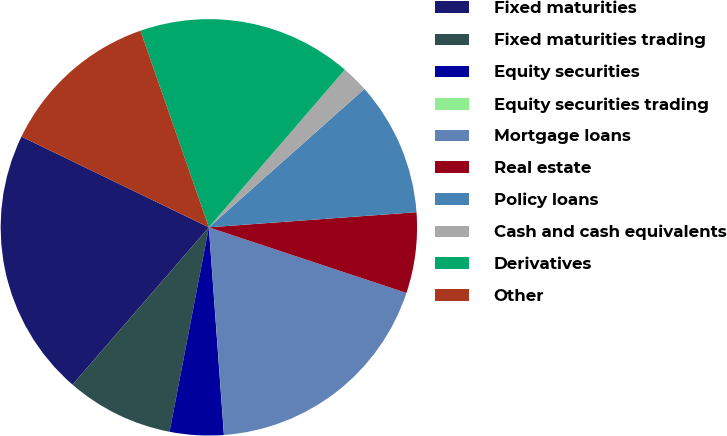Convert chart to OTSL. <chart><loc_0><loc_0><loc_500><loc_500><pie_chart><fcel>Fixed maturities<fcel>Fixed maturities trading<fcel>Equity securities<fcel>Equity securities trading<fcel>Mortgage loans<fcel>Real estate<fcel>Policy loans<fcel>Cash and cash equivalents<fcel>Derivatives<fcel>Other<nl><fcel>20.82%<fcel>8.34%<fcel>4.18%<fcel>0.01%<fcel>18.74%<fcel>6.26%<fcel>10.42%<fcel>2.1%<fcel>16.66%<fcel>12.5%<nl></chart> 